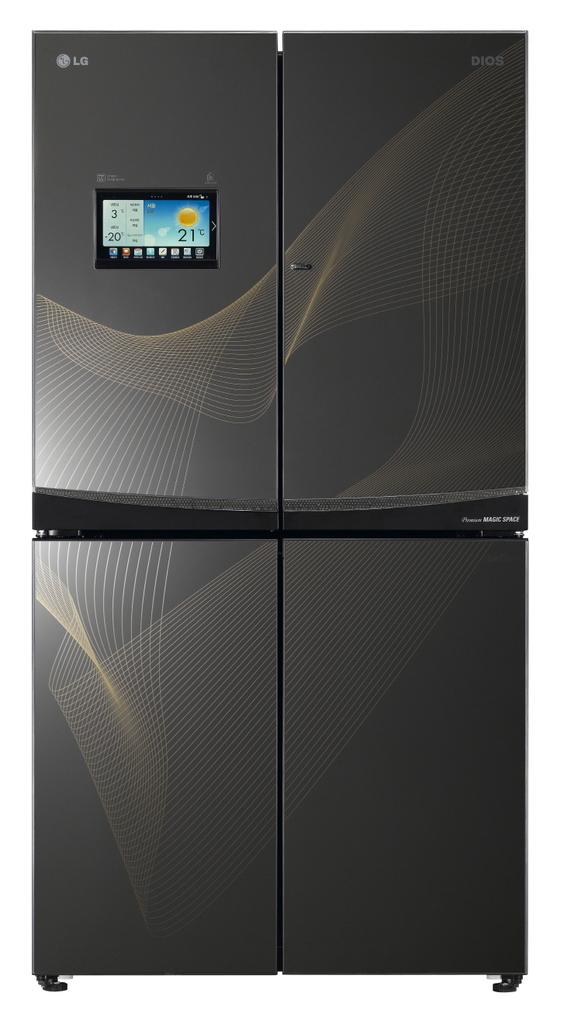Provide a one-sentence caption for the provided image. The black appliance here is from the company LG. 